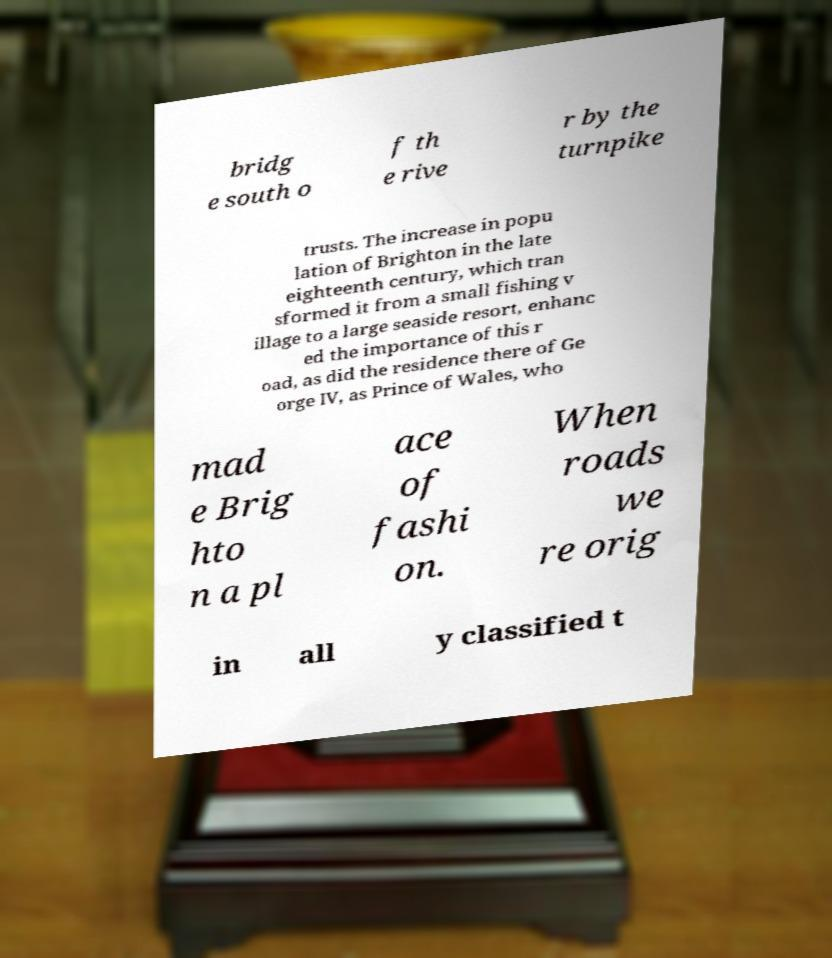Can you accurately transcribe the text from the provided image for me? bridg e south o f th e rive r by the turnpike trusts. The increase in popu lation of Brighton in the late eighteenth century, which tran sformed it from a small fishing v illage to a large seaside resort, enhanc ed the importance of this r oad, as did the residence there of Ge orge IV, as Prince of Wales, who mad e Brig hto n a pl ace of fashi on. When roads we re orig in all y classified t 